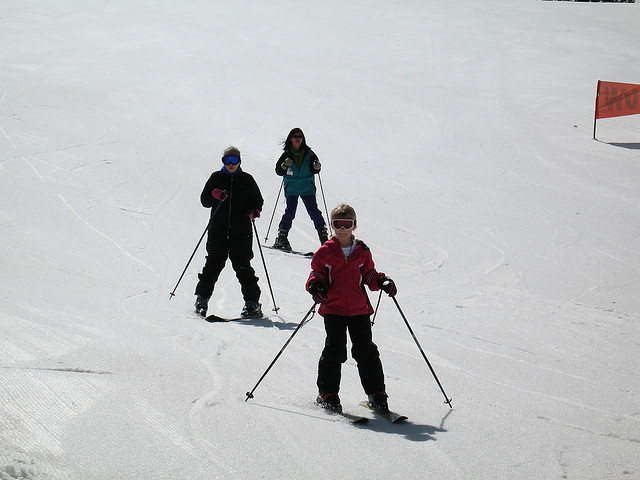<image>What country is this in? I'm not sure what country this is in. It could be USA, Canada, or Austria. What country is this in? I don't know what country this is in. However, it can be seen in the USA, Canada, or Austria. 